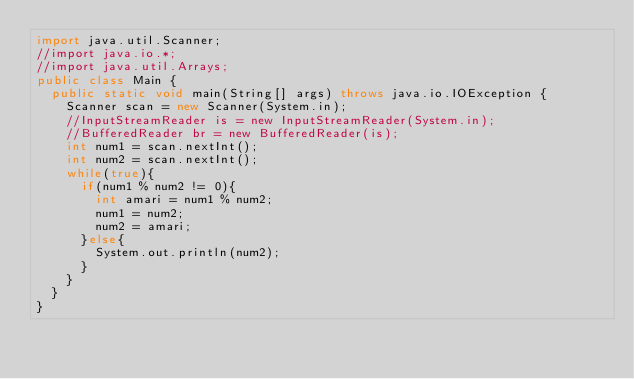Convert code to text. <code><loc_0><loc_0><loc_500><loc_500><_Java_>import java.util.Scanner;
//import java.io.*;
//import java.util.Arrays;
public class Main {
	public static void main(String[] args) throws java.io.IOException {
		Scanner scan = new Scanner(System.in);
		//InputStreamReader is = new InputStreamReader(System.in);
		//BufferedReader br = new BufferedReader(is);
		int num1 = scan.nextInt();
		int num2 = scan.nextInt();
		while(true){
			if(num1 % num2 != 0){
				int amari = num1 % num2;
				num1 = num2;
				num2 = amari;
			}else{
				System.out.println(num2);
			}
		}
	}
}</code> 